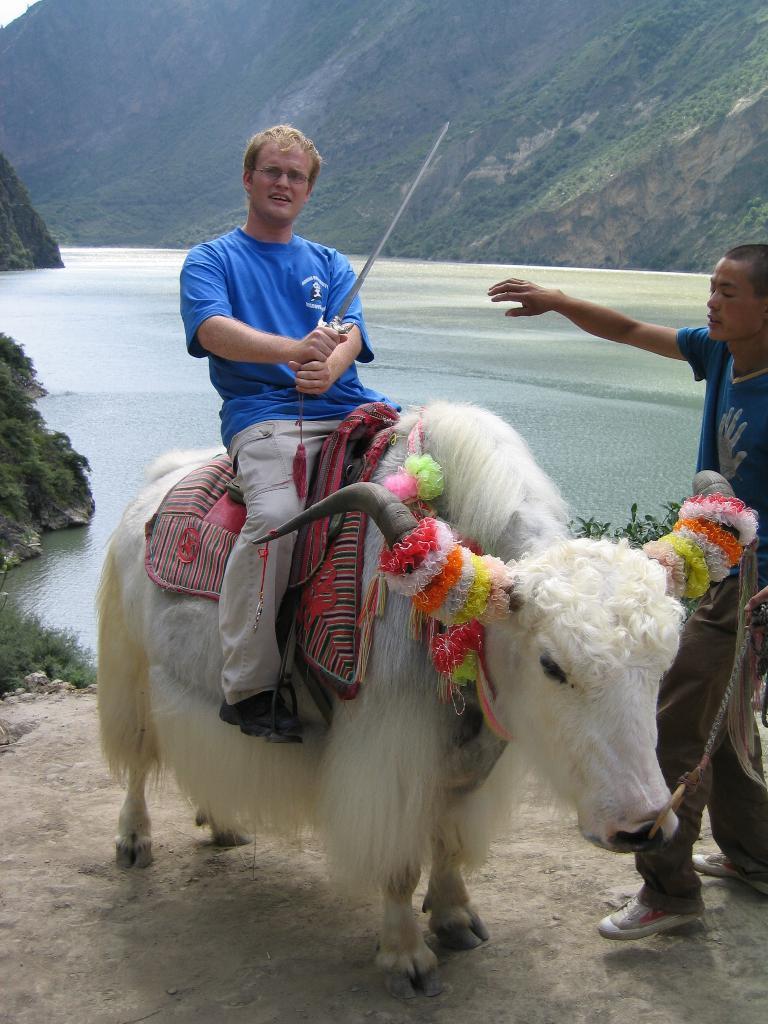In one or two sentences, can you explain what this image depicts? In the image there is an ox it is decorated with some ribbons and a person is sitting on the ox by holding a knife, beside the ox there is another person and in the background there is a sea and there are mountains around the sea. 